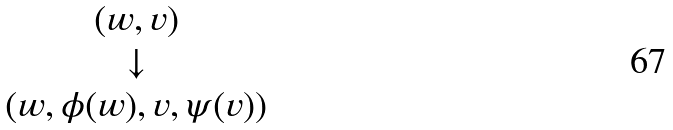<formula> <loc_0><loc_0><loc_500><loc_500>\begin{matrix} ( w , v ) \\ \downarrow \\ ( w , \phi ( w ) , v , \psi ( v ) ) \end{matrix}</formula> 